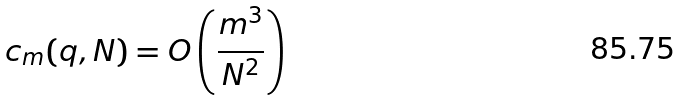Convert formula to latex. <formula><loc_0><loc_0><loc_500><loc_500>c _ { m } ( q , N ) = O \left ( \frac { m ^ { 3 } } { N ^ { 2 } } \right )</formula> 